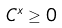<formula> <loc_0><loc_0><loc_500><loc_500>C ^ { x } \geq 0</formula> 